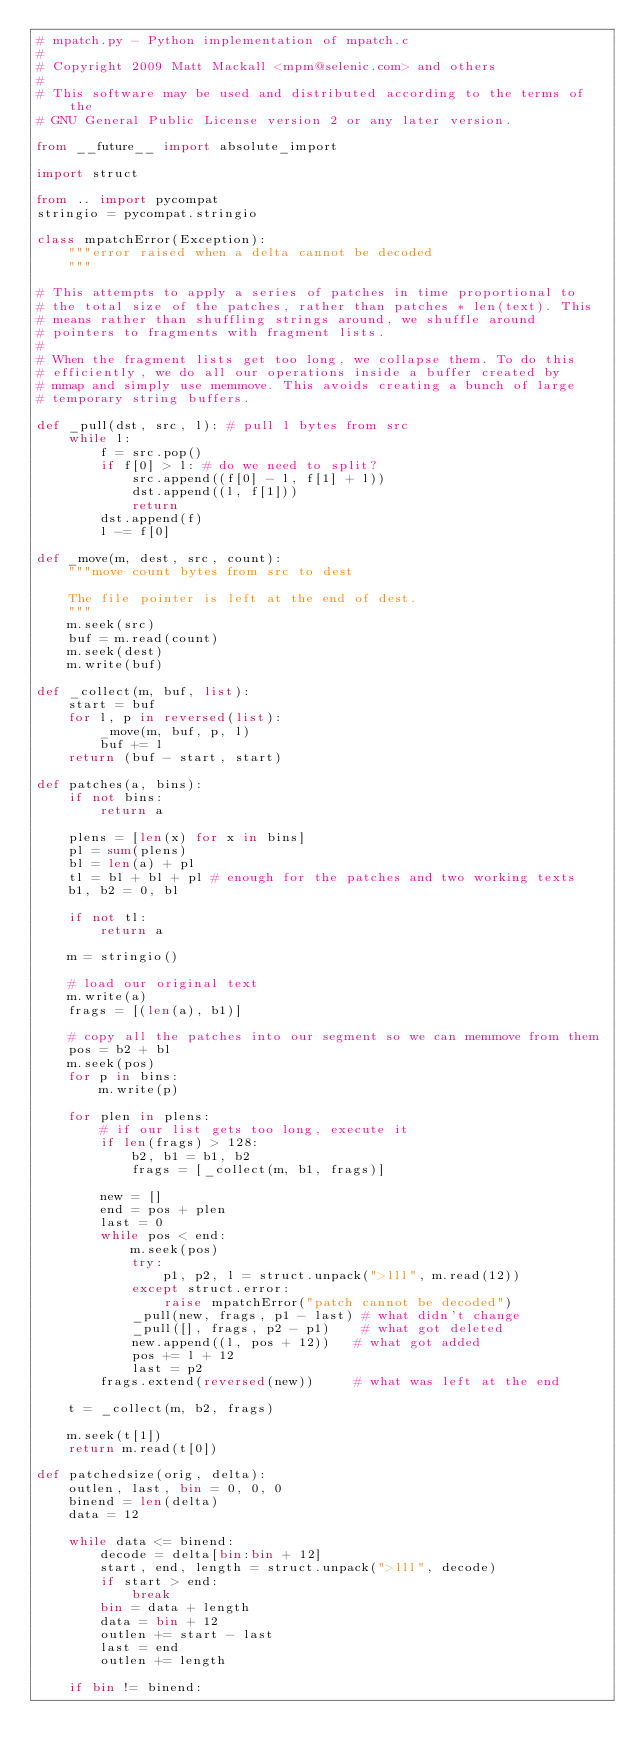Convert code to text. <code><loc_0><loc_0><loc_500><loc_500><_Python_># mpatch.py - Python implementation of mpatch.c
#
# Copyright 2009 Matt Mackall <mpm@selenic.com> and others
#
# This software may be used and distributed according to the terms of the
# GNU General Public License version 2 or any later version.

from __future__ import absolute_import

import struct

from .. import pycompat
stringio = pycompat.stringio

class mpatchError(Exception):
    """error raised when a delta cannot be decoded
    """

# This attempts to apply a series of patches in time proportional to
# the total size of the patches, rather than patches * len(text). This
# means rather than shuffling strings around, we shuffle around
# pointers to fragments with fragment lists.
#
# When the fragment lists get too long, we collapse them. To do this
# efficiently, we do all our operations inside a buffer created by
# mmap and simply use memmove. This avoids creating a bunch of large
# temporary string buffers.

def _pull(dst, src, l): # pull l bytes from src
    while l:
        f = src.pop()
        if f[0] > l: # do we need to split?
            src.append((f[0] - l, f[1] + l))
            dst.append((l, f[1]))
            return
        dst.append(f)
        l -= f[0]

def _move(m, dest, src, count):
    """move count bytes from src to dest

    The file pointer is left at the end of dest.
    """
    m.seek(src)
    buf = m.read(count)
    m.seek(dest)
    m.write(buf)

def _collect(m, buf, list):
    start = buf
    for l, p in reversed(list):
        _move(m, buf, p, l)
        buf += l
    return (buf - start, start)

def patches(a, bins):
    if not bins:
        return a

    plens = [len(x) for x in bins]
    pl = sum(plens)
    bl = len(a) + pl
    tl = bl + bl + pl # enough for the patches and two working texts
    b1, b2 = 0, bl

    if not tl:
        return a

    m = stringio()

    # load our original text
    m.write(a)
    frags = [(len(a), b1)]

    # copy all the patches into our segment so we can memmove from them
    pos = b2 + bl
    m.seek(pos)
    for p in bins:
        m.write(p)

    for plen in plens:
        # if our list gets too long, execute it
        if len(frags) > 128:
            b2, b1 = b1, b2
            frags = [_collect(m, b1, frags)]

        new = []
        end = pos + plen
        last = 0
        while pos < end:
            m.seek(pos)
            try:
                p1, p2, l = struct.unpack(">lll", m.read(12))
            except struct.error:
                raise mpatchError("patch cannot be decoded")
            _pull(new, frags, p1 - last) # what didn't change
            _pull([], frags, p2 - p1)    # what got deleted
            new.append((l, pos + 12))   # what got added
            pos += l + 12
            last = p2
        frags.extend(reversed(new))     # what was left at the end

    t = _collect(m, b2, frags)

    m.seek(t[1])
    return m.read(t[0])

def patchedsize(orig, delta):
    outlen, last, bin = 0, 0, 0
    binend = len(delta)
    data = 12

    while data <= binend:
        decode = delta[bin:bin + 12]
        start, end, length = struct.unpack(">lll", decode)
        if start > end:
            break
        bin = data + length
        data = bin + 12
        outlen += start - last
        last = end
        outlen += length

    if bin != binend:</code> 